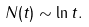Convert formula to latex. <formula><loc_0><loc_0><loc_500><loc_500>N ( t ) \sim \ln t .</formula> 